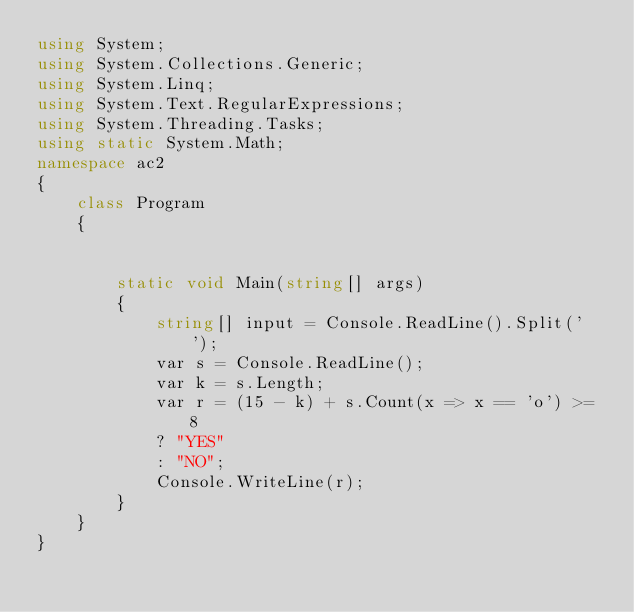Convert code to text. <code><loc_0><loc_0><loc_500><loc_500><_C#_>using System;
using System.Collections.Generic;
using System.Linq;
using System.Text.RegularExpressions;
using System.Threading.Tasks;
using static System.Math;
namespace ac2
{
    class Program
    {


        static void Main(string[] args)
        {
            string[] input = Console.ReadLine().Split(' ');
            var s = Console.ReadLine();
            var k = s.Length;
            var r = (15 - k) + s.Count(x => x == 'o') >= 8
            ? "YES"
            : "NO";
            Console.WriteLine(r);
        }
    }
}</code> 